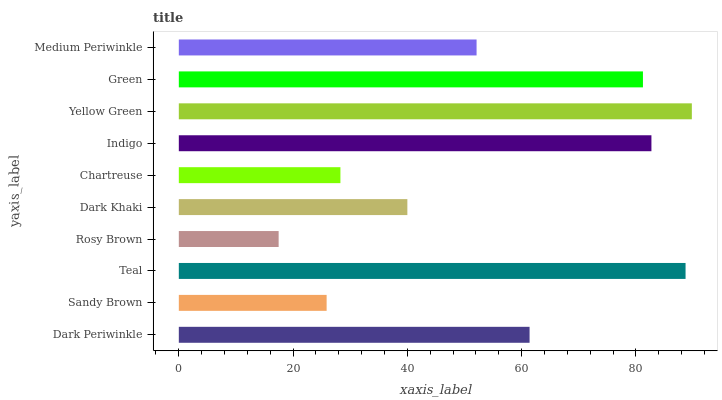Is Rosy Brown the minimum?
Answer yes or no. Yes. Is Yellow Green the maximum?
Answer yes or no. Yes. Is Sandy Brown the minimum?
Answer yes or no. No. Is Sandy Brown the maximum?
Answer yes or no. No. Is Dark Periwinkle greater than Sandy Brown?
Answer yes or no. Yes. Is Sandy Brown less than Dark Periwinkle?
Answer yes or no. Yes. Is Sandy Brown greater than Dark Periwinkle?
Answer yes or no. No. Is Dark Periwinkle less than Sandy Brown?
Answer yes or no. No. Is Dark Periwinkle the high median?
Answer yes or no. Yes. Is Medium Periwinkle the low median?
Answer yes or no. Yes. Is Medium Periwinkle the high median?
Answer yes or no. No. Is Dark Khaki the low median?
Answer yes or no. No. 